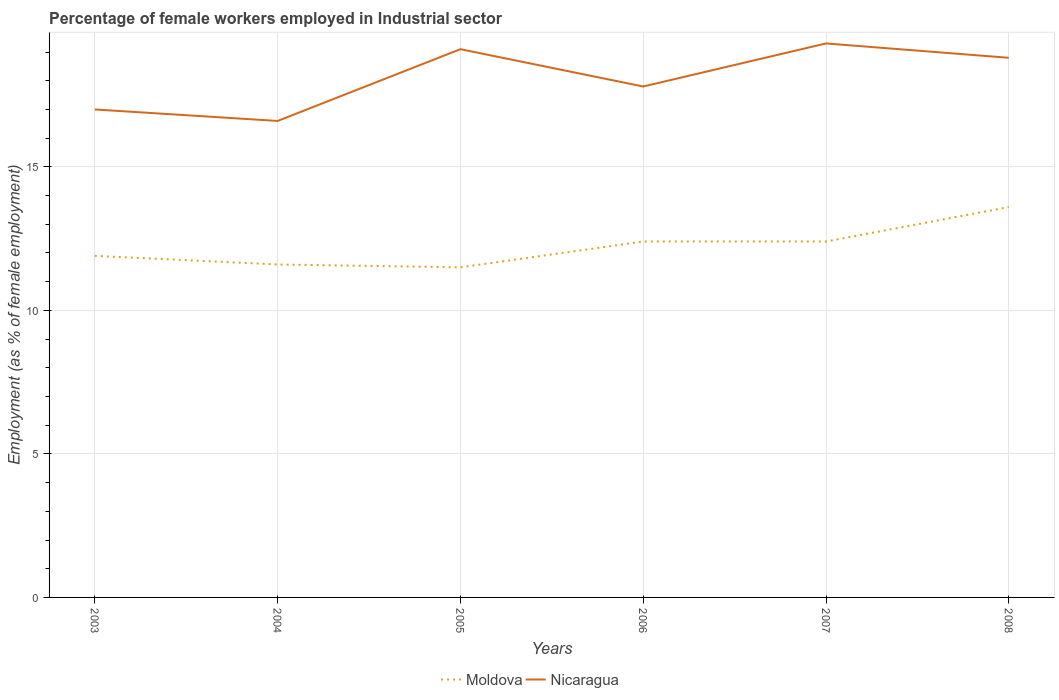Across all years, what is the maximum percentage of females employed in Industrial sector in Nicaragua?
Ensure brevity in your answer.  16.6. In which year was the percentage of females employed in Industrial sector in Moldova maximum?
Provide a short and direct response. 2005. What is the total percentage of females employed in Industrial sector in Nicaragua in the graph?
Offer a very short reply. -0.2. What is the difference between the highest and the second highest percentage of females employed in Industrial sector in Nicaragua?
Your answer should be very brief. 2.7. What is the difference between the highest and the lowest percentage of females employed in Industrial sector in Moldova?
Your answer should be very brief. 3. How many lines are there?
Make the answer very short. 2. How many years are there in the graph?
Your answer should be very brief. 6. What is the difference between two consecutive major ticks on the Y-axis?
Make the answer very short. 5. Does the graph contain any zero values?
Ensure brevity in your answer.  No. What is the title of the graph?
Ensure brevity in your answer.  Percentage of female workers employed in Industrial sector. What is the label or title of the Y-axis?
Give a very brief answer. Employment (as % of female employment). What is the Employment (as % of female employment) of Moldova in 2003?
Give a very brief answer. 11.9. What is the Employment (as % of female employment) in Moldova in 2004?
Your answer should be compact. 11.6. What is the Employment (as % of female employment) of Nicaragua in 2004?
Offer a very short reply. 16.6. What is the Employment (as % of female employment) of Nicaragua in 2005?
Provide a succinct answer. 19.1. What is the Employment (as % of female employment) in Moldova in 2006?
Provide a succinct answer. 12.4. What is the Employment (as % of female employment) in Nicaragua in 2006?
Your answer should be very brief. 17.8. What is the Employment (as % of female employment) in Moldova in 2007?
Keep it short and to the point. 12.4. What is the Employment (as % of female employment) of Nicaragua in 2007?
Your response must be concise. 19.3. What is the Employment (as % of female employment) of Moldova in 2008?
Keep it short and to the point. 13.6. What is the Employment (as % of female employment) in Nicaragua in 2008?
Offer a very short reply. 18.8. Across all years, what is the maximum Employment (as % of female employment) of Moldova?
Give a very brief answer. 13.6. Across all years, what is the maximum Employment (as % of female employment) in Nicaragua?
Ensure brevity in your answer.  19.3. Across all years, what is the minimum Employment (as % of female employment) of Moldova?
Offer a very short reply. 11.5. Across all years, what is the minimum Employment (as % of female employment) of Nicaragua?
Your response must be concise. 16.6. What is the total Employment (as % of female employment) of Moldova in the graph?
Give a very brief answer. 73.4. What is the total Employment (as % of female employment) in Nicaragua in the graph?
Provide a short and direct response. 108.6. What is the difference between the Employment (as % of female employment) of Nicaragua in 2003 and that in 2004?
Give a very brief answer. 0.4. What is the difference between the Employment (as % of female employment) of Nicaragua in 2003 and that in 2005?
Your response must be concise. -2.1. What is the difference between the Employment (as % of female employment) in Moldova in 2003 and that in 2006?
Your response must be concise. -0.5. What is the difference between the Employment (as % of female employment) in Nicaragua in 2003 and that in 2006?
Provide a short and direct response. -0.8. What is the difference between the Employment (as % of female employment) in Nicaragua in 2003 and that in 2008?
Make the answer very short. -1.8. What is the difference between the Employment (as % of female employment) of Moldova in 2004 and that in 2005?
Ensure brevity in your answer.  0.1. What is the difference between the Employment (as % of female employment) of Nicaragua in 2004 and that in 2005?
Your response must be concise. -2.5. What is the difference between the Employment (as % of female employment) in Moldova in 2004 and that in 2006?
Offer a terse response. -0.8. What is the difference between the Employment (as % of female employment) in Nicaragua in 2004 and that in 2006?
Provide a succinct answer. -1.2. What is the difference between the Employment (as % of female employment) in Nicaragua in 2004 and that in 2008?
Provide a short and direct response. -2.2. What is the difference between the Employment (as % of female employment) of Moldova in 2005 and that in 2008?
Offer a very short reply. -2.1. What is the difference between the Employment (as % of female employment) of Moldova in 2006 and that in 2007?
Offer a terse response. 0. What is the difference between the Employment (as % of female employment) of Nicaragua in 2006 and that in 2007?
Offer a terse response. -1.5. What is the difference between the Employment (as % of female employment) of Moldova in 2006 and that in 2008?
Make the answer very short. -1.2. What is the difference between the Employment (as % of female employment) of Moldova in 2007 and that in 2008?
Offer a very short reply. -1.2. What is the difference between the Employment (as % of female employment) in Nicaragua in 2007 and that in 2008?
Your answer should be very brief. 0.5. What is the difference between the Employment (as % of female employment) in Moldova in 2003 and the Employment (as % of female employment) in Nicaragua in 2005?
Your answer should be compact. -7.2. What is the difference between the Employment (as % of female employment) of Moldova in 2003 and the Employment (as % of female employment) of Nicaragua in 2007?
Make the answer very short. -7.4. What is the difference between the Employment (as % of female employment) of Moldova in 2004 and the Employment (as % of female employment) of Nicaragua in 2005?
Offer a terse response. -7.5. What is the difference between the Employment (as % of female employment) of Moldova in 2004 and the Employment (as % of female employment) of Nicaragua in 2007?
Provide a short and direct response. -7.7. What is the difference between the Employment (as % of female employment) of Moldova in 2004 and the Employment (as % of female employment) of Nicaragua in 2008?
Provide a short and direct response. -7.2. What is the difference between the Employment (as % of female employment) in Moldova in 2005 and the Employment (as % of female employment) in Nicaragua in 2006?
Give a very brief answer. -6.3. What is the difference between the Employment (as % of female employment) of Moldova in 2005 and the Employment (as % of female employment) of Nicaragua in 2008?
Keep it short and to the point. -7.3. What is the difference between the Employment (as % of female employment) of Moldova in 2006 and the Employment (as % of female employment) of Nicaragua in 2007?
Give a very brief answer. -6.9. What is the difference between the Employment (as % of female employment) in Moldova in 2006 and the Employment (as % of female employment) in Nicaragua in 2008?
Your response must be concise. -6.4. What is the average Employment (as % of female employment) of Moldova per year?
Keep it short and to the point. 12.23. In the year 2003, what is the difference between the Employment (as % of female employment) of Moldova and Employment (as % of female employment) of Nicaragua?
Offer a very short reply. -5.1. In the year 2004, what is the difference between the Employment (as % of female employment) of Moldova and Employment (as % of female employment) of Nicaragua?
Your answer should be compact. -5. In the year 2005, what is the difference between the Employment (as % of female employment) in Moldova and Employment (as % of female employment) in Nicaragua?
Offer a terse response. -7.6. In the year 2007, what is the difference between the Employment (as % of female employment) of Moldova and Employment (as % of female employment) of Nicaragua?
Offer a terse response. -6.9. In the year 2008, what is the difference between the Employment (as % of female employment) of Moldova and Employment (as % of female employment) of Nicaragua?
Offer a very short reply. -5.2. What is the ratio of the Employment (as % of female employment) in Moldova in 2003 to that in 2004?
Your response must be concise. 1.03. What is the ratio of the Employment (as % of female employment) of Nicaragua in 2003 to that in 2004?
Provide a short and direct response. 1.02. What is the ratio of the Employment (as % of female employment) of Moldova in 2003 to that in 2005?
Ensure brevity in your answer.  1.03. What is the ratio of the Employment (as % of female employment) of Nicaragua in 2003 to that in 2005?
Provide a short and direct response. 0.89. What is the ratio of the Employment (as % of female employment) in Moldova in 2003 to that in 2006?
Ensure brevity in your answer.  0.96. What is the ratio of the Employment (as % of female employment) of Nicaragua in 2003 to that in 2006?
Your response must be concise. 0.96. What is the ratio of the Employment (as % of female employment) of Moldova in 2003 to that in 2007?
Provide a succinct answer. 0.96. What is the ratio of the Employment (as % of female employment) in Nicaragua in 2003 to that in 2007?
Offer a very short reply. 0.88. What is the ratio of the Employment (as % of female employment) of Moldova in 2003 to that in 2008?
Your response must be concise. 0.88. What is the ratio of the Employment (as % of female employment) of Nicaragua in 2003 to that in 2008?
Keep it short and to the point. 0.9. What is the ratio of the Employment (as % of female employment) of Moldova in 2004 to that in 2005?
Make the answer very short. 1.01. What is the ratio of the Employment (as % of female employment) of Nicaragua in 2004 to that in 2005?
Make the answer very short. 0.87. What is the ratio of the Employment (as % of female employment) of Moldova in 2004 to that in 2006?
Offer a very short reply. 0.94. What is the ratio of the Employment (as % of female employment) of Nicaragua in 2004 to that in 2006?
Provide a succinct answer. 0.93. What is the ratio of the Employment (as % of female employment) of Moldova in 2004 to that in 2007?
Provide a short and direct response. 0.94. What is the ratio of the Employment (as % of female employment) of Nicaragua in 2004 to that in 2007?
Your answer should be very brief. 0.86. What is the ratio of the Employment (as % of female employment) in Moldova in 2004 to that in 2008?
Make the answer very short. 0.85. What is the ratio of the Employment (as % of female employment) of Nicaragua in 2004 to that in 2008?
Ensure brevity in your answer.  0.88. What is the ratio of the Employment (as % of female employment) of Moldova in 2005 to that in 2006?
Keep it short and to the point. 0.93. What is the ratio of the Employment (as % of female employment) in Nicaragua in 2005 to that in 2006?
Provide a succinct answer. 1.07. What is the ratio of the Employment (as % of female employment) of Moldova in 2005 to that in 2007?
Keep it short and to the point. 0.93. What is the ratio of the Employment (as % of female employment) of Moldova in 2005 to that in 2008?
Your answer should be compact. 0.85. What is the ratio of the Employment (as % of female employment) of Nicaragua in 2005 to that in 2008?
Ensure brevity in your answer.  1.02. What is the ratio of the Employment (as % of female employment) in Nicaragua in 2006 to that in 2007?
Offer a very short reply. 0.92. What is the ratio of the Employment (as % of female employment) of Moldova in 2006 to that in 2008?
Keep it short and to the point. 0.91. What is the ratio of the Employment (as % of female employment) in Nicaragua in 2006 to that in 2008?
Your answer should be compact. 0.95. What is the ratio of the Employment (as % of female employment) of Moldova in 2007 to that in 2008?
Ensure brevity in your answer.  0.91. What is the ratio of the Employment (as % of female employment) in Nicaragua in 2007 to that in 2008?
Provide a succinct answer. 1.03. What is the difference between the highest and the lowest Employment (as % of female employment) in Nicaragua?
Keep it short and to the point. 2.7. 